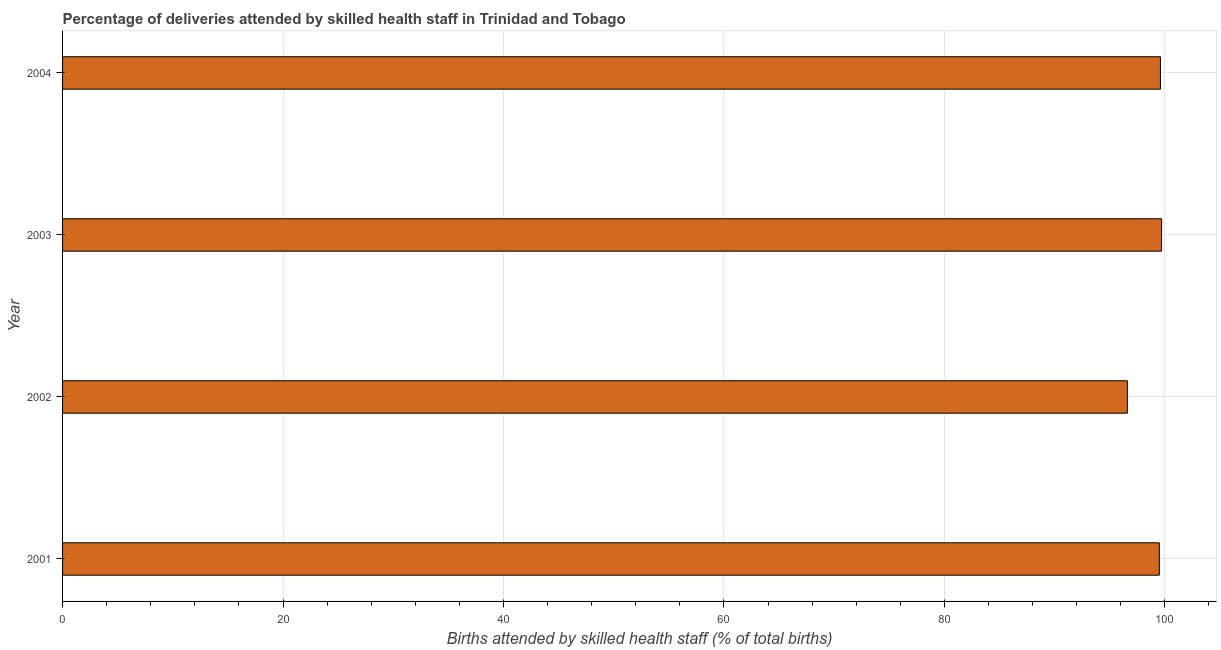What is the title of the graph?
Provide a short and direct response. Percentage of deliveries attended by skilled health staff in Trinidad and Tobago. What is the label or title of the X-axis?
Offer a terse response. Births attended by skilled health staff (% of total births). What is the label or title of the Y-axis?
Offer a very short reply. Year. What is the number of births attended by skilled health staff in 2002?
Your answer should be very brief. 96.6. Across all years, what is the maximum number of births attended by skilled health staff?
Your response must be concise. 99.7. Across all years, what is the minimum number of births attended by skilled health staff?
Make the answer very short. 96.6. In which year was the number of births attended by skilled health staff maximum?
Provide a short and direct response. 2003. What is the sum of the number of births attended by skilled health staff?
Ensure brevity in your answer.  395.4. What is the difference between the number of births attended by skilled health staff in 2002 and 2003?
Provide a short and direct response. -3.1. What is the average number of births attended by skilled health staff per year?
Offer a terse response. 98.85. What is the median number of births attended by skilled health staff?
Give a very brief answer. 99.55. In how many years, is the number of births attended by skilled health staff greater than 60 %?
Your answer should be compact. 4. Do a majority of the years between 2003 and 2004 (inclusive) have number of births attended by skilled health staff greater than 28 %?
Keep it short and to the point. Yes. Is the number of births attended by skilled health staff in 2001 less than that in 2002?
Give a very brief answer. No. Is the difference between the number of births attended by skilled health staff in 2003 and 2004 greater than the difference between any two years?
Provide a succinct answer. No. In how many years, is the number of births attended by skilled health staff greater than the average number of births attended by skilled health staff taken over all years?
Your response must be concise. 3. How many bars are there?
Ensure brevity in your answer.  4. Are all the bars in the graph horizontal?
Keep it short and to the point. Yes. What is the difference between two consecutive major ticks on the X-axis?
Keep it short and to the point. 20. Are the values on the major ticks of X-axis written in scientific E-notation?
Keep it short and to the point. No. What is the Births attended by skilled health staff (% of total births) of 2001?
Ensure brevity in your answer.  99.5. What is the Births attended by skilled health staff (% of total births) of 2002?
Your answer should be very brief. 96.6. What is the Births attended by skilled health staff (% of total births) in 2003?
Your answer should be compact. 99.7. What is the Births attended by skilled health staff (% of total births) of 2004?
Provide a short and direct response. 99.6. What is the difference between the Births attended by skilled health staff (% of total births) in 2001 and 2004?
Your response must be concise. -0.1. What is the difference between the Births attended by skilled health staff (% of total births) in 2002 and 2004?
Provide a succinct answer. -3. What is the difference between the Births attended by skilled health staff (% of total births) in 2003 and 2004?
Provide a short and direct response. 0.1. What is the ratio of the Births attended by skilled health staff (% of total births) in 2001 to that in 2003?
Your response must be concise. 1. What is the ratio of the Births attended by skilled health staff (% of total births) in 2002 to that in 2003?
Give a very brief answer. 0.97. 